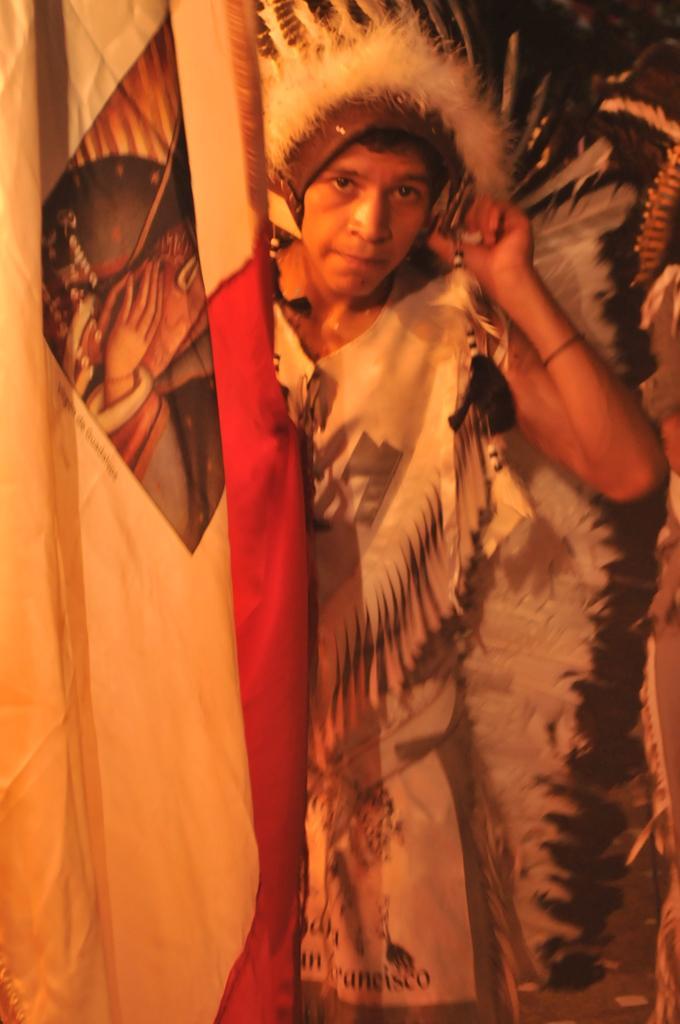Could you give a brief overview of what you see in this image? In this picture, we see the woman who is wearing the white and black costume is standing. On the left side, we see a sheet or a cloth in white and red color. 